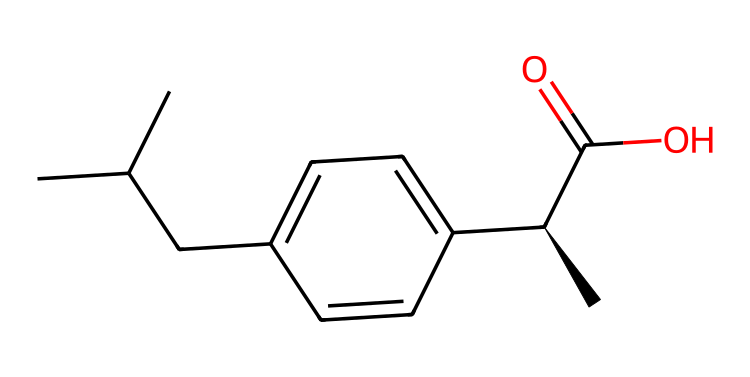What is the molecular formula of ibuprofen? To derive the molecular formula from the provided SMILES representation, we identify the elements and count their occurrences. In the SMILES, 'C' denotes carbon, 'H' represents hydrogen, and 'O' is for oxygen. The chemical structure shows 13 carbons, 18 hydrogens, and 2 oxygens, leading to the formula C13H18O2.
Answer: C13H18O2 How many rings are present in ibuprofen's structure? Examining the chemical structure, we search for cyclical components that would indicate rings. The SMILES does not feature any indications of rings (like parentheses or special characters), which shows that ibuprofen has a linear structure with no rings present.
Answer: 0 What type of functional group is present in ibuprofen? By looking at the functional groups in the SMILES, there is a carboxylic acid group (indicated by the C(=O)O), common in pain relievers, confirming the primary functional group characterizing ibuprofen.
Answer: carboxylic acid Which part of the structure indicates its chiral nature? In the provided SMILES, the presence of '[C@H]' indicates a specific stereocenter or chiral carbon atom. This notation signifies that this carbon atom has four different substituents, confirming that ibuprofen has a stereogenic center, making it chiral.
Answer: [C@H] What is the primary use of ibuprofen in a busy professional's life? The common use of ibuprofen, reflected in its design as a pain reliever, aligns with the demands of busy professionals requiring pain management and relief from inflammation during hectic work schedules.
Answer: pain reliever Is ibuprofen a simple or complex molecule based on its structure? The structure contains multiple carbon and functional groups, which leads to the conclusion that ibuprofen is a relatively complex molecule as compared to simple organic compounds like alkanes.
Answer: complex 